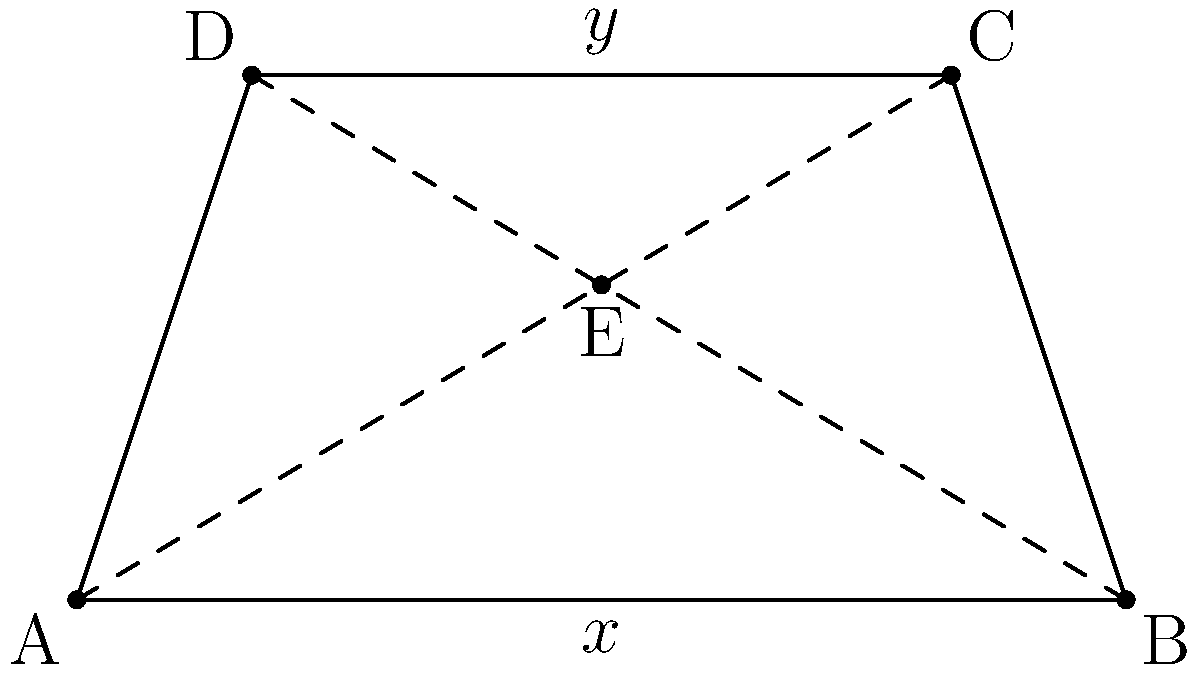In the isosceles trapezoid $ABCD$, the diagonals $AC$ and $BD$ intersect at point $E$. If the bases of the trapezoid are $x$ and $y$, with $x > y$, prove that $AE:EC = BE:ED = x:y$. Let's approach this step-by-step:

1) In an isosceles trapezoid, the legs are equal in length, and the diagonals are equal in length.

2) The diagonals of a trapezoid divide each other proportionally. This means that $AE:EC = BE:ED$.

3) Let's focus on triangle $AEB$:
   - $AB$ is the base of the trapezoid, so its length is $x$.
   - $E$ is on the diagonal $BD$.
   - The ratio $AE:EB$ is the same as the ratio of the areas of triangles $AED$ and $BEC$.

4) The areas of these triangles can be expressed as:
   - Area of $AED = \frac{1}{2} \cdot AD \cdot y$
   - Area of $BEC = \frac{1}{2} \cdot BC \cdot y$

5) Since $ABCD$ is isosceles, $AD = BC$. Therefore, the ratio of these areas is the same as the ratio of the bases of the trapezoid:

   $\frac{Area(AED)}{Area(BEC)} = \frac{y}{x}$

6) This means that $BE:AE = x:y$, or $AE:BE = y:x$.

7) Combining this with the result from step 2, we can conclude that:

   $AE:EC = BE:ED = y:x$

8) Inverting the ratios, we get the desired result:

   $AE:EC = BE:ED = x:y$

Thus, we have proven that $AE:EC = BE:ED = x:y$.
Answer: $AE:EC = BE:ED = x:y$ 